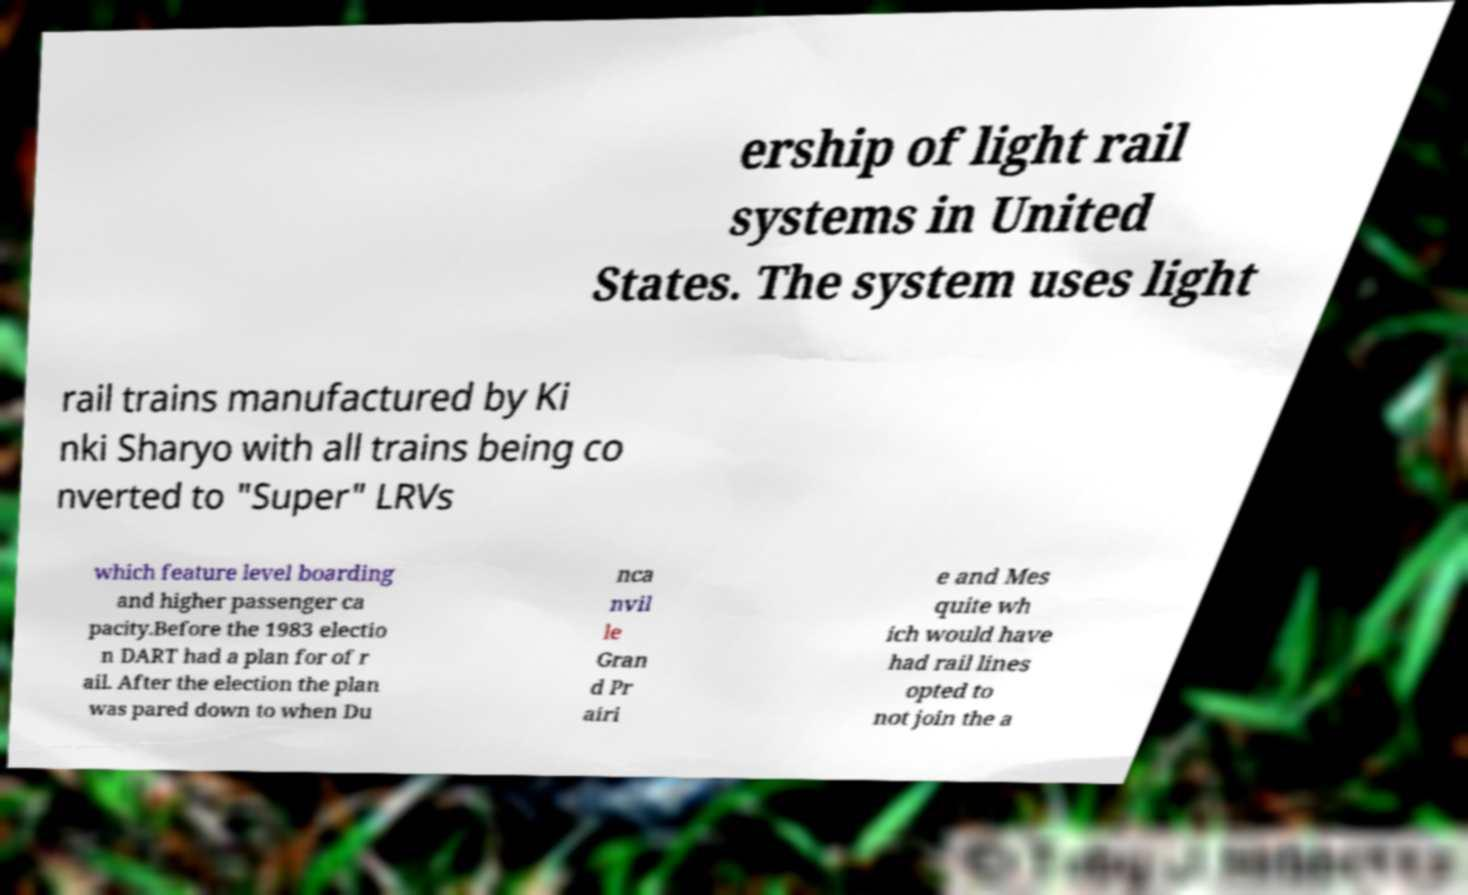Please identify and transcribe the text found in this image. ership of light rail systems in United States. The system uses light rail trains manufactured by Ki nki Sharyo with all trains being co nverted to "Super" LRVs which feature level boarding and higher passenger ca pacity.Before the 1983 electio n DART had a plan for of r ail. After the election the plan was pared down to when Du nca nvil le Gran d Pr airi e and Mes quite wh ich would have had rail lines opted to not join the a 